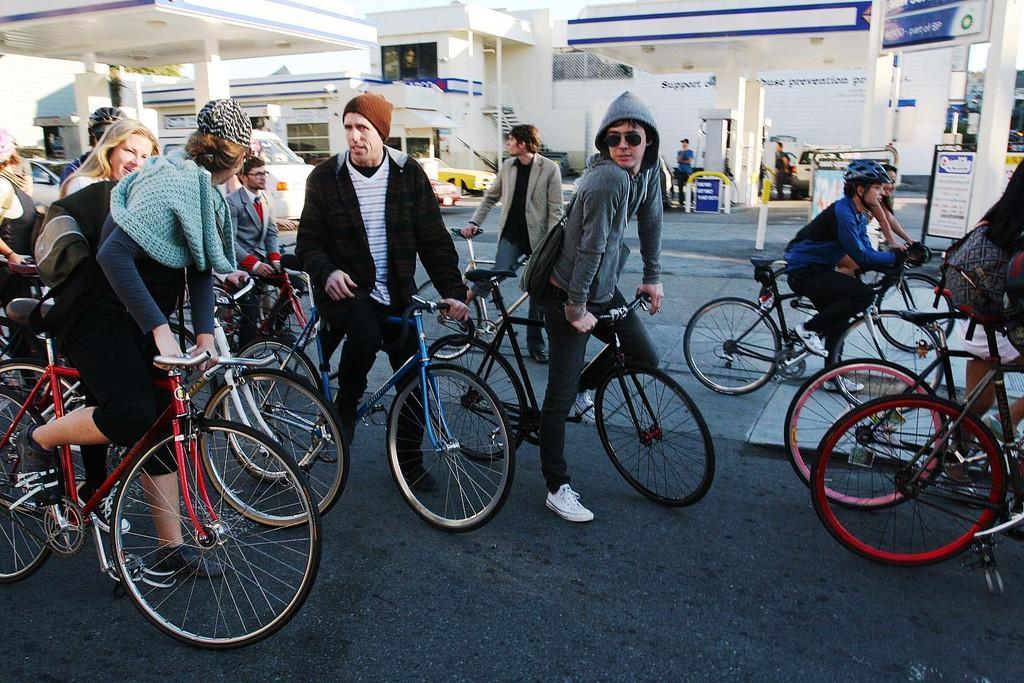How would you summarize this image in a sentence or two? here in this picture we can see the persons standing with a bicycle on the road,here we can also see petrol bunk near to the person,here we can see some vehicles in the petrol bunk. 